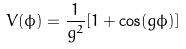Convert formula to latex. <formula><loc_0><loc_0><loc_500><loc_500>V ( \phi ) = \frac { 1 } { g ^ { 2 } } [ 1 + \cos ( g \phi ) ]</formula> 